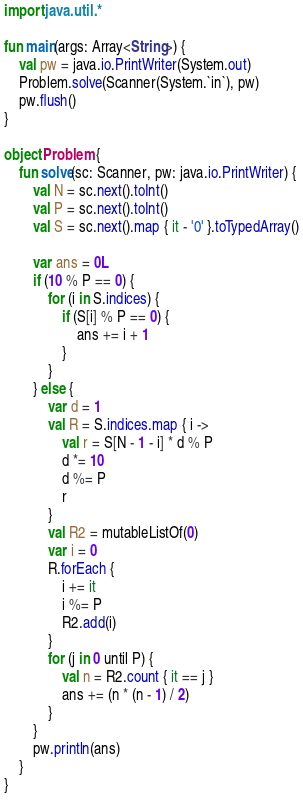Convert code to text. <code><loc_0><loc_0><loc_500><loc_500><_Kotlin_>import java.util.*

fun main(args: Array<String>) {
    val pw = java.io.PrintWriter(System.out)
    Problem.solve(Scanner(System.`in`), pw)
    pw.flush()
}

object Problem {
    fun solve(sc: Scanner, pw: java.io.PrintWriter) {
        val N = sc.next().toInt()
        val P = sc.next().toInt()
        val S = sc.next().map { it - '0' }.toTypedArray()

        var ans = 0L
        if (10 % P == 0) {
            for (i in S.indices) {
                if (S[i] % P == 0) {
                    ans += i + 1
                }
            }
        } else {
            var d = 1
            val R = S.indices.map { i ->
                val r = S[N - 1 - i] * d % P
                d *= 10
                d %= P
                r
            }
            val R2 = mutableListOf(0)
            var i = 0
            R.forEach {
                i += it
                i %= P
                R2.add(i)
            }
            for (j in 0 until P) {
                val n = R2.count { it == j }
                ans += (n * (n - 1) / 2)
            }
        }
        pw.println(ans)
    }
}
</code> 